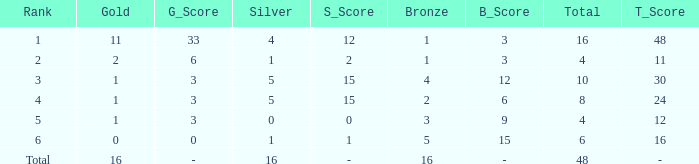How many gold are a rank 1 and larger than 16? 0.0. 